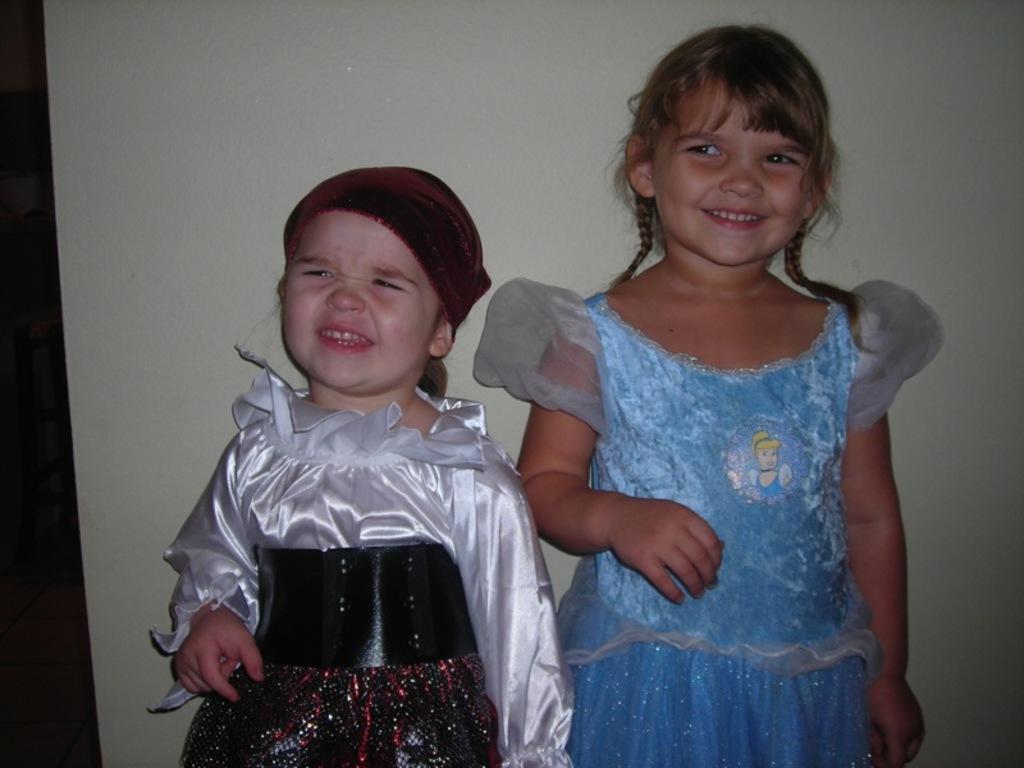How would you summarize this image in a sentence or two? As we can see in the image there is white color wall and two girls standing. The girl standing on the right side is wearing sky blue color dress and the girl standing on the left side is wearing silver color dress. 